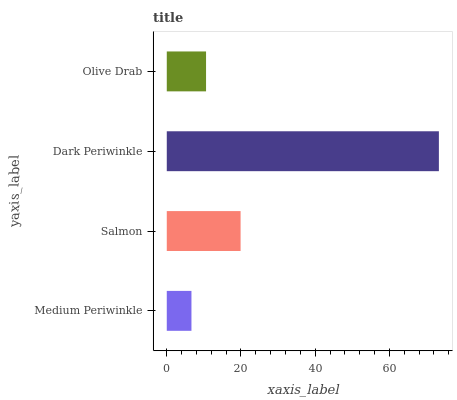Is Medium Periwinkle the minimum?
Answer yes or no. Yes. Is Dark Periwinkle the maximum?
Answer yes or no. Yes. Is Salmon the minimum?
Answer yes or no. No. Is Salmon the maximum?
Answer yes or no. No. Is Salmon greater than Medium Periwinkle?
Answer yes or no. Yes. Is Medium Periwinkle less than Salmon?
Answer yes or no. Yes. Is Medium Periwinkle greater than Salmon?
Answer yes or no. No. Is Salmon less than Medium Periwinkle?
Answer yes or no. No. Is Salmon the high median?
Answer yes or no. Yes. Is Olive Drab the low median?
Answer yes or no. Yes. Is Olive Drab the high median?
Answer yes or no. No. Is Dark Periwinkle the low median?
Answer yes or no. No. 